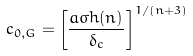Convert formula to latex. <formula><loc_0><loc_0><loc_500><loc_500>c _ { 0 , G } = \left [ \frac { a \sigma h ( n ) } { \delta _ { c } } \right ] ^ { 1 / ( n + 3 ) }</formula> 